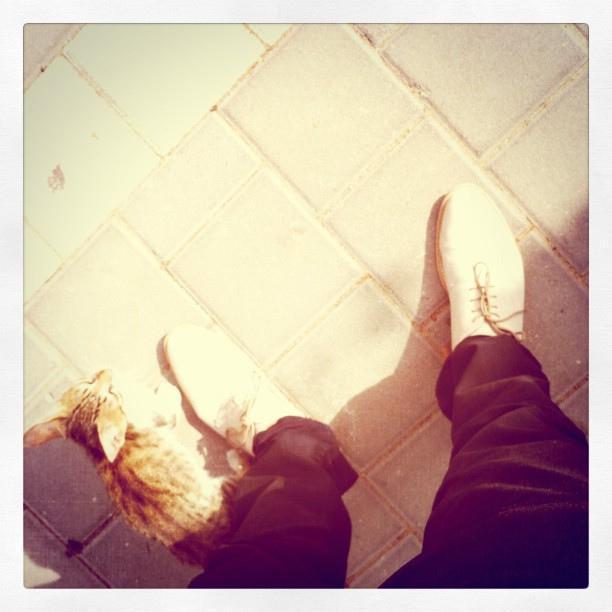How many oxygen tubes is the man in the bed wearing?
Give a very brief answer. 0. 